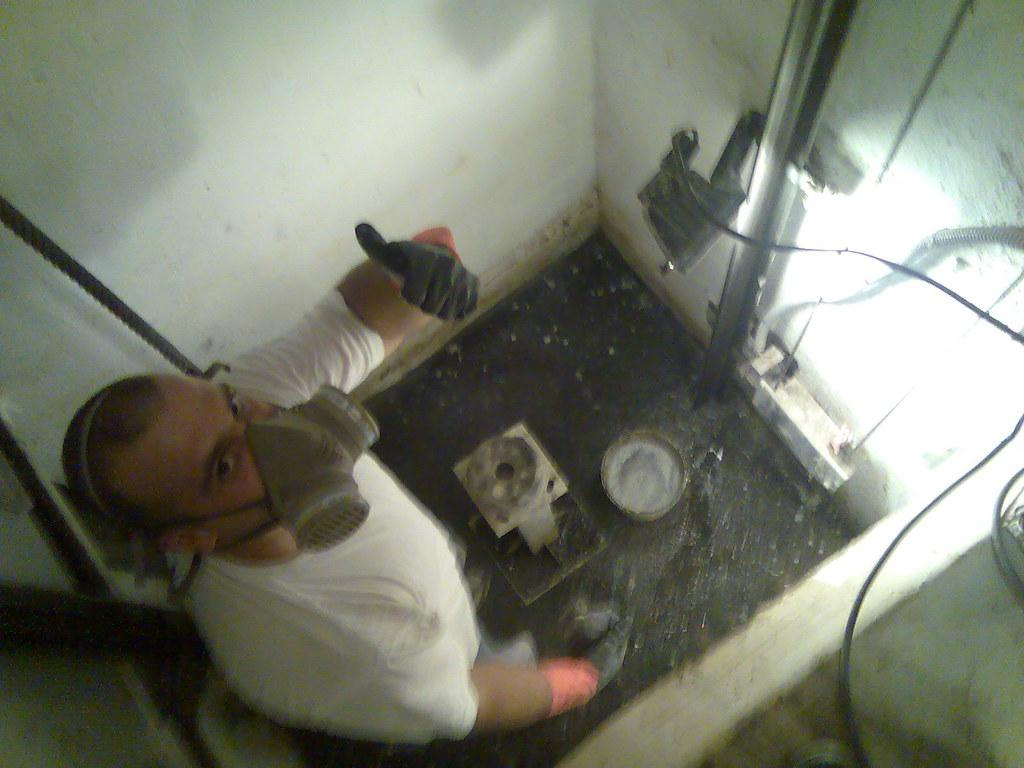What can be seen in the image related to a person? There is a person in the image, and they are wearing a mask and a white shirt. What is the person doing in the image? The person is standing in the image. What objects are present in the image besides the person? There is a bucket, a metal rod, and wires in the image. What can be said about the wall in the image? The wall is white in color. Can you see a field or a bear in the image? No, there is no field or bear present in the image. Is there a road visible in the image? No, there is no road visible in the image. 